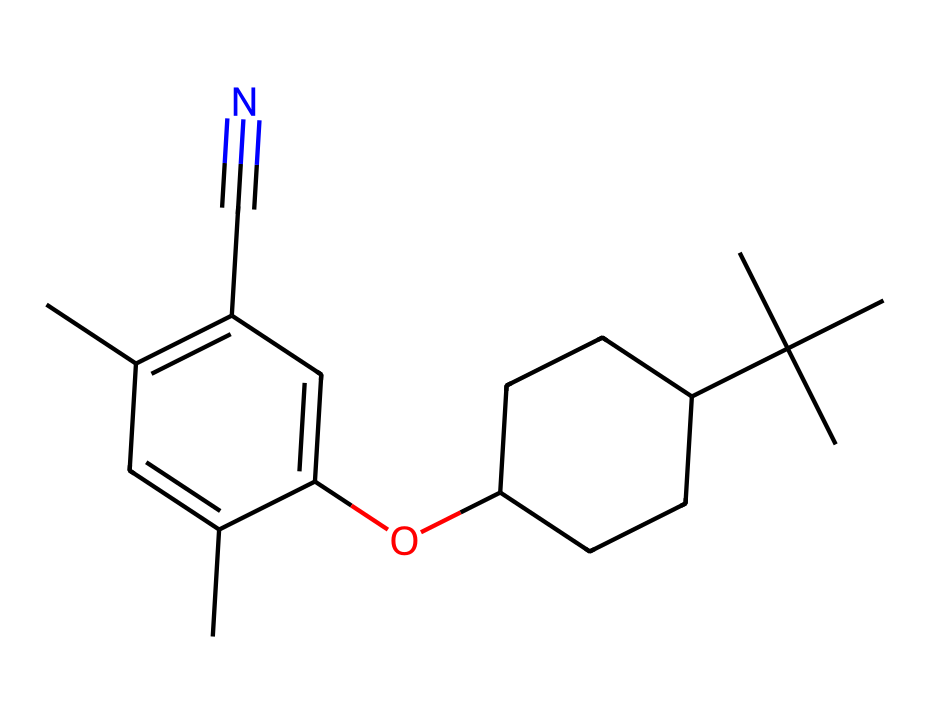What is the total number of carbon atoms in this compound? The SMILES representation shows a series of carbon atoms connected in various configurations. By counting the 'C' present in the structure, we determine there are 18 carbon atoms.
Answer: 18 How many double bonds are present in the chemical structure? The presence of double bonds can be identified by the '=' symbols in the SMILES. This representation indicates there are two double bonds in the chemical.
Answer: 2 What type of functional group is indicated by the presence of 'C#N'? The presence of the 'C#N' in the SMILES indicates a cyano group, which is characterized by a carbon triple-bonded to a nitrogen atom.
Answer: cyano Which type of hybridization is likely predominant for the carbon atoms in this compound? Given the structure includes alkenes (due to double bonds) and other carbon atoms, these carbon atoms will primarily exhibit sp2 hybridization, which is typical for compounds with double bonds.
Answer: sp2 What property does the presence of the methoxy group (-OCH3) suggest about the chemical's polarity? The methoxy group adds oxygen to the structure, which increases the polarity of the molecule. This property is common in compounds that include ether functional groups, suggesting moderate to high polarity.
Answer: increased polarity Which part of this chemical suggests that it could be used in liquid crystals? The presence of both aromatic rings and various functional groups (like the cyano and methoxy groups) suggests that the compound has the necessary structural characteristics to exhibit liquid crystalline behavior, commonly needed for LCD applications.
Answer: aromatic rings and functional groups 